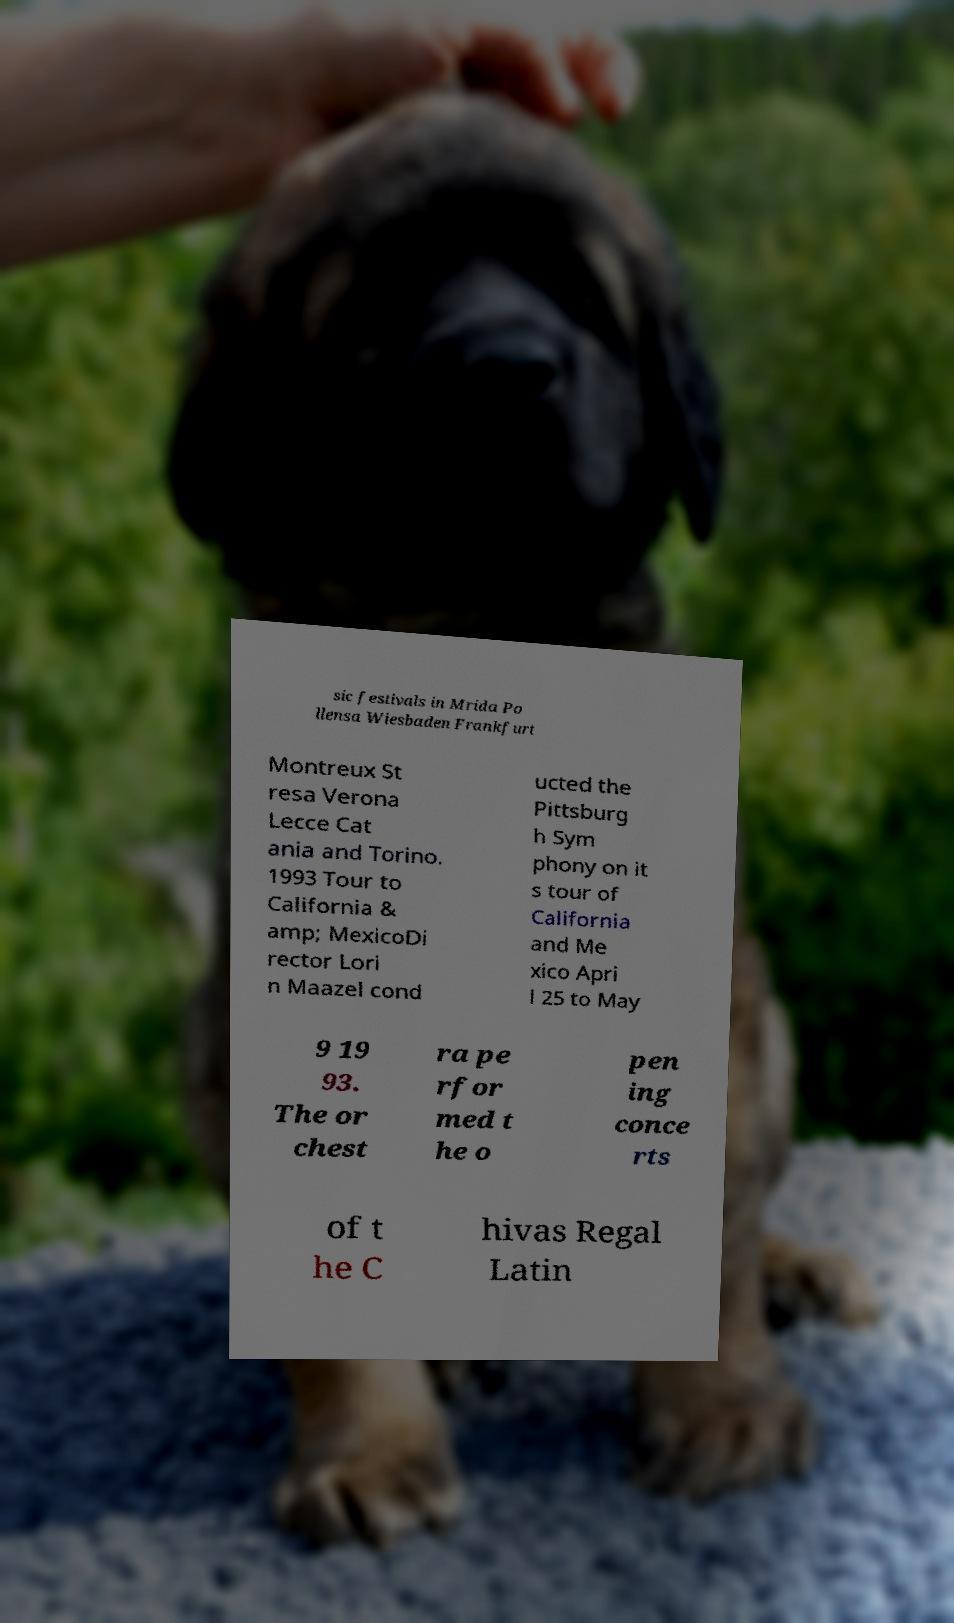Can you accurately transcribe the text from the provided image for me? sic festivals in Mrida Po llensa Wiesbaden Frankfurt Montreux St resa Verona Lecce Cat ania and Torino. 1993 Tour to California & amp; MexicoDi rector Lori n Maazel cond ucted the Pittsburg h Sym phony on it s tour of California and Me xico Apri l 25 to May 9 19 93. The or chest ra pe rfor med t he o pen ing conce rts of t he C hivas Regal Latin 